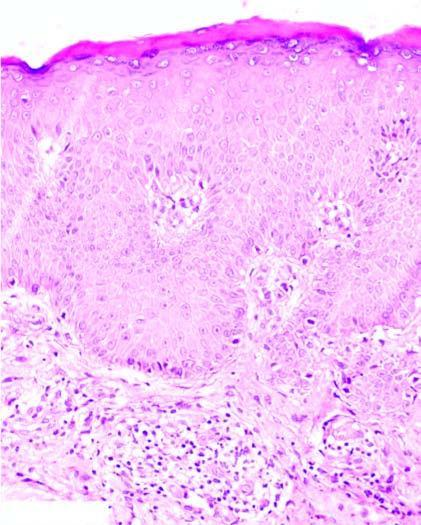what does the epidermis show?
Answer the question using a single word or phrase. Hyperkeratosis 